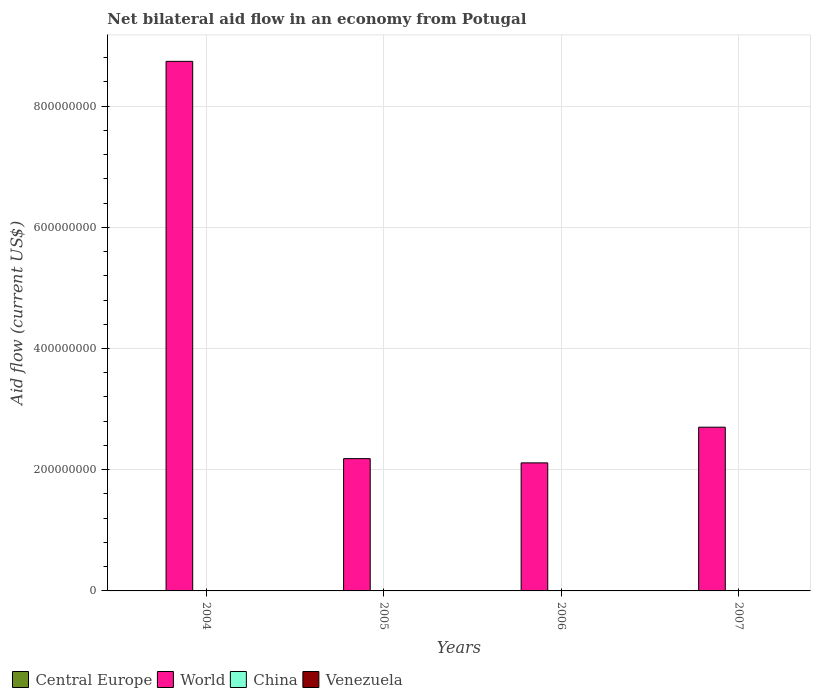How many different coloured bars are there?
Offer a very short reply. 4. How many groups of bars are there?
Provide a succinct answer. 4. Are the number of bars per tick equal to the number of legend labels?
Make the answer very short. Yes. How many bars are there on the 3rd tick from the left?
Provide a short and direct response. 4. In how many cases, is the number of bars for a given year not equal to the number of legend labels?
Provide a short and direct response. 0. Across all years, what is the maximum net bilateral aid flow in Central Europe?
Your answer should be compact. 5.50e+05. Across all years, what is the minimum net bilateral aid flow in Venezuela?
Make the answer very short. 8.00e+04. In which year was the net bilateral aid flow in Venezuela maximum?
Your answer should be very brief. 2007. What is the total net bilateral aid flow in Venezuela in the graph?
Make the answer very short. 4.40e+05. What is the difference between the net bilateral aid flow in World in 2004 and that in 2007?
Provide a succinct answer. 6.04e+08. What is the difference between the net bilateral aid flow in Central Europe in 2007 and the net bilateral aid flow in World in 2006?
Offer a terse response. -2.11e+08. In the year 2005, what is the difference between the net bilateral aid flow in China and net bilateral aid flow in Venezuela?
Give a very brief answer. 1.70e+05. In how many years, is the net bilateral aid flow in Venezuela greater than 640000000 US$?
Make the answer very short. 0. What is the ratio of the net bilateral aid flow in Central Europe in 2004 to that in 2007?
Offer a terse response. 4.58. What is the difference between the highest and the lowest net bilateral aid flow in China?
Offer a very short reply. 1.70e+05. In how many years, is the net bilateral aid flow in Venezuela greater than the average net bilateral aid flow in Venezuela taken over all years?
Offer a very short reply. 1. Is it the case that in every year, the sum of the net bilateral aid flow in Central Europe and net bilateral aid flow in China is greater than the sum of net bilateral aid flow in World and net bilateral aid flow in Venezuela?
Provide a short and direct response. No. What does the 1st bar from the left in 2004 represents?
Ensure brevity in your answer.  Central Europe. What does the 4th bar from the right in 2006 represents?
Your answer should be compact. Central Europe. Is it the case that in every year, the sum of the net bilateral aid flow in Venezuela and net bilateral aid flow in China is greater than the net bilateral aid flow in Central Europe?
Keep it short and to the point. No. How many bars are there?
Provide a short and direct response. 16. Are the values on the major ticks of Y-axis written in scientific E-notation?
Provide a succinct answer. No. Where does the legend appear in the graph?
Provide a succinct answer. Bottom left. How are the legend labels stacked?
Offer a terse response. Horizontal. What is the title of the graph?
Your answer should be very brief. Net bilateral aid flow in an economy from Potugal. What is the label or title of the X-axis?
Provide a succinct answer. Years. What is the label or title of the Y-axis?
Your answer should be very brief. Aid flow (current US$). What is the Aid flow (current US$) of Central Europe in 2004?
Offer a very short reply. 5.50e+05. What is the Aid flow (current US$) in World in 2004?
Your answer should be very brief. 8.74e+08. What is the Aid flow (current US$) in Venezuela in 2004?
Ensure brevity in your answer.  8.00e+04. What is the Aid flow (current US$) of Central Europe in 2005?
Offer a terse response. 5.00e+04. What is the Aid flow (current US$) in World in 2005?
Provide a short and direct response. 2.18e+08. What is the Aid flow (current US$) of China in 2005?
Give a very brief answer. 2.70e+05. What is the Aid flow (current US$) in Venezuela in 2005?
Your response must be concise. 1.00e+05. What is the Aid flow (current US$) in Central Europe in 2006?
Offer a very short reply. 8.00e+04. What is the Aid flow (current US$) in World in 2006?
Give a very brief answer. 2.11e+08. What is the Aid flow (current US$) of Venezuela in 2006?
Make the answer very short. 1.10e+05. What is the Aid flow (current US$) in Central Europe in 2007?
Make the answer very short. 1.20e+05. What is the Aid flow (current US$) of World in 2007?
Give a very brief answer. 2.70e+08. What is the Aid flow (current US$) of China in 2007?
Ensure brevity in your answer.  1.50e+05. What is the Aid flow (current US$) of Venezuela in 2007?
Offer a terse response. 1.50e+05. Across all years, what is the maximum Aid flow (current US$) in Central Europe?
Give a very brief answer. 5.50e+05. Across all years, what is the maximum Aid flow (current US$) in World?
Provide a short and direct response. 8.74e+08. Across all years, what is the maximum Aid flow (current US$) in China?
Ensure brevity in your answer.  3.00e+05. Across all years, what is the maximum Aid flow (current US$) of Venezuela?
Make the answer very short. 1.50e+05. Across all years, what is the minimum Aid flow (current US$) of Central Europe?
Provide a succinct answer. 5.00e+04. Across all years, what is the minimum Aid flow (current US$) of World?
Make the answer very short. 2.11e+08. Across all years, what is the minimum Aid flow (current US$) in Venezuela?
Keep it short and to the point. 8.00e+04. What is the total Aid flow (current US$) in Central Europe in the graph?
Give a very brief answer. 8.00e+05. What is the total Aid flow (current US$) of World in the graph?
Make the answer very short. 1.57e+09. What is the total Aid flow (current US$) of China in the graph?
Provide a short and direct response. 8.50e+05. What is the total Aid flow (current US$) in Venezuela in the graph?
Make the answer very short. 4.40e+05. What is the difference between the Aid flow (current US$) in World in 2004 and that in 2005?
Give a very brief answer. 6.56e+08. What is the difference between the Aid flow (current US$) of China in 2004 and that in 2005?
Provide a succinct answer. 3.00e+04. What is the difference between the Aid flow (current US$) in Venezuela in 2004 and that in 2005?
Your answer should be very brief. -2.00e+04. What is the difference between the Aid flow (current US$) in World in 2004 and that in 2006?
Offer a very short reply. 6.63e+08. What is the difference between the Aid flow (current US$) of Venezuela in 2004 and that in 2006?
Make the answer very short. -3.00e+04. What is the difference between the Aid flow (current US$) in World in 2004 and that in 2007?
Provide a succinct answer. 6.04e+08. What is the difference between the Aid flow (current US$) in Venezuela in 2004 and that in 2007?
Give a very brief answer. -7.00e+04. What is the difference between the Aid flow (current US$) of World in 2005 and that in 2006?
Keep it short and to the point. 7.01e+06. What is the difference between the Aid flow (current US$) in China in 2005 and that in 2006?
Provide a succinct answer. 1.40e+05. What is the difference between the Aid flow (current US$) in Venezuela in 2005 and that in 2006?
Provide a succinct answer. -10000. What is the difference between the Aid flow (current US$) of World in 2005 and that in 2007?
Provide a succinct answer. -5.19e+07. What is the difference between the Aid flow (current US$) of World in 2006 and that in 2007?
Offer a very short reply. -5.89e+07. What is the difference between the Aid flow (current US$) of Venezuela in 2006 and that in 2007?
Give a very brief answer. -4.00e+04. What is the difference between the Aid flow (current US$) of Central Europe in 2004 and the Aid flow (current US$) of World in 2005?
Give a very brief answer. -2.18e+08. What is the difference between the Aid flow (current US$) in Central Europe in 2004 and the Aid flow (current US$) in China in 2005?
Your answer should be very brief. 2.80e+05. What is the difference between the Aid flow (current US$) of Central Europe in 2004 and the Aid flow (current US$) of Venezuela in 2005?
Provide a short and direct response. 4.50e+05. What is the difference between the Aid flow (current US$) of World in 2004 and the Aid flow (current US$) of China in 2005?
Ensure brevity in your answer.  8.74e+08. What is the difference between the Aid flow (current US$) in World in 2004 and the Aid flow (current US$) in Venezuela in 2005?
Ensure brevity in your answer.  8.74e+08. What is the difference between the Aid flow (current US$) in China in 2004 and the Aid flow (current US$) in Venezuela in 2005?
Provide a short and direct response. 2.00e+05. What is the difference between the Aid flow (current US$) in Central Europe in 2004 and the Aid flow (current US$) in World in 2006?
Your response must be concise. -2.11e+08. What is the difference between the Aid flow (current US$) in Central Europe in 2004 and the Aid flow (current US$) in Venezuela in 2006?
Your response must be concise. 4.40e+05. What is the difference between the Aid flow (current US$) of World in 2004 and the Aid flow (current US$) of China in 2006?
Provide a succinct answer. 8.74e+08. What is the difference between the Aid flow (current US$) of World in 2004 and the Aid flow (current US$) of Venezuela in 2006?
Provide a short and direct response. 8.74e+08. What is the difference between the Aid flow (current US$) in Central Europe in 2004 and the Aid flow (current US$) in World in 2007?
Ensure brevity in your answer.  -2.70e+08. What is the difference between the Aid flow (current US$) of Central Europe in 2004 and the Aid flow (current US$) of China in 2007?
Offer a terse response. 4.00e+05. What is the difference between the Aid flow (current US$) of Central Europe in 2004 and the Aid flow (current US$) of Venezuela in 2007?
Offer a terse response. 4.00e+05. What is the difference between the Aid flow (current US$) of World in 2004 and the Aid flow (current US$) of China in 2007?
Your answer should be compact. 8.74e+08. What is the difference between the Aid flow (current US$) of World in 2004 and the Aid flow (current US$) of Venezuela in 2007?
Keep it short and to the point. 8.74e+08. What is the difference between the Aid flow (current US$) in Central Europe in 2005 and the Aid flow (current US$) in World in 2006?
Your answer should be very brief. -2.11e+08. What is the difference between the Aid flow (current US$) of Central Europe in 2005 and the Aid flow (current US$) of China in 2006?
Offer a terse response. -8.00e+04. What is the difference between the Aid flow (current US$) of World in 2005 and the Aid flow (current US$) of China in 2006?
Your answer should be very brief. 2.18e+08. What is the difference between the Aid flow (current US$) of World in 2005 and the Aid flow (current US$) of Venezuela in 2006?
Provide a short and direct response. 2.18e+08. What is the difference between the Aid flow (current US$) of Central Europe in 2005 and the Aid flow (current US$) of World in 2007?
Your answer should be compact. -2.70e+08. What is the difference between the Aid flow (current US$) of Central Europe in 2005 and the Aid flow (current US$) of Venezuela in 2007?
Offer a terse response. -1.00e+05. What is the difference between the Aid flow (current US$) of World in 2005 and the Aid flow (current US$) of China in 2007?
Provide a succinct answer. 2.18e+08. What is the difference between the Aid flow (current US$) of World in 2005 and the Aid flow (current US$) of Venezuela in 2007?
Provide a short and direct response. 2.18e+08. What is the difference between the Aid flow (current US$) in China in 2005 and the Aid flow (current US$) in Venezuela in 2007?
Offer a very short reply. 1.20e+05. What is the difference between the Aid flow (current US$) of Central Europe in 2006 and the Aid flow (current US$) of World in 2007?
Give a very brief answer. -2.70e+08. What is the difference between the Aid flow (current US$) in Central Europe in 2006 and the Aid flow (current US$) in China in 2007?
Provide a succinct answer. -7.00e+04. What is the difference between the Aid flow (current US$) in Central Europe in 2006 and the Aid flow (current US$) in Venezuela in 2007?
Keep it short and to the point. -7.00e+04. What is the difference between the Aid flow (current US$) in World in 2006 and the Aid flow (current US$) in China in 2007?
Make the answer very short. 2.11e+08. What is the difference between the Aid flow (current US$) of World in 2006 and the Aid flow (current US$) of Venezuela in 2007?
Provide a succinct answer. 2.11e+08. What is the average Aid flow (current US$) in Central Europe per year?
Your answer should be very brief. 2.00e+05. What is the average Aid flow (current US$) of World per year?
Give a very brief answer. 3.93e+08. What is the average Aid flow (current US$) of China per year?
Offer a terse response. 2.12e+05. What is the average Aid flow (current US$) of Venezuela per year?
Make the answer very short. 1.10e+05. In the year 2004, what is the difference between the Aid flow (current US$) in Central Europe and Aid flow (current US$) in World?
Offer a very short reply. -8.73e+08. In the year 2004, what is the difference between the Aid flow (current US$) of Central Europe and Aid flow (current US$) of China?
Your response must be concise. 2.50e+05. In the year 2004, what is the difference between the Aid flow (current US$) in World and Aid flow (current US$) in China?
Your answer should be very brief. 8.74e+08. In the year 2004, what is the difference between the Aid flow (current US$) in World and Aid flow (current US$) in Venezuela?
Offer a terse response. 8.74e+08. In the year 2004, what is the difference between the Aid flow (current US$) in China and Aid flow (current US$) in Venezuela?
Your answer should be very brief. 2.20e+05. In the year 2005, what is the difference between the Aid flow (current US$) in Central Europe and Aid flow (current US$) in World?
Offer a terse response. -2.18e+08. In the year 2005, what is the difference between the Aid flow (current US$) in World and Aid flow (current US$) in China?
Provide a short and direct response. 2.18e+08. In the year 2005, what is the difference between the Aid flow (current US$) of World and Aid flow (current US$) of Venezuela?
Your answer should be compact. 2.18e+08. In the year 2005, what is the difference between the Aid flow (current US$) in China and Aid flow (current US$) in Venezuela?
Provide a short and direct response. 1.70e+05. In the year 2006, what is the difference between the Aid flow (current US$) of Central Europe and Aid flow (current US$) of World?
Your answer should be very brief. -2.11e+08. In the year 2006, what is the difference between the Aid flow (current US$) of Central Europe and Aid flow (current US$) of China?
Ensure brevity in your answer.  -5.00e+04. In the year 2006, what is the difference between the Aid flow (current US$) in World and Aid flow (current US$) in China?
Ensure brevity in your answer.  2.11e+08. In the year 2006, what is the difference between the Aid flow (current US$) in World and Aid flow (current US$) in Venezuela?
Your answer should be very brief. 2.11e+08. In the year 2006, what is the difference between the Aid flow (current US$) in China and Aid flow (current US$) in Venezuela?
Give a very brief answer. 2.00e+04. In the year 2007, what is the difference between the Aid flow (current US$) in Central Europe and Aid flow (current US$) in World?
Give a very brief answer. -2.70e+08. In the year 2007, what is the difference between the Aid flow (current US$) in Central Europe and Aid flow (current US$) in China?
Give a very brief answer. -3.00e+04. In the year 2007, what is the difference between the Aid flow (current US$) of Central Europe and Aid flow (current US$) of Venezuela?
Make the answer very short. -3.00e+04. In the year 2007, what is the difference between the Aid flow (current US$) of World and Aid flow (current US$) of China?
Give a very brief answer. 2.70e+08. In the year 2007, what is the difference between the Aid flow (current US$) of World and Aid flow (current US$) of Venezuela?
Offer a very short reply. 2.70e+08. In the year 2007, what is the difference between the Aid flow (current US$) in China and Aid flow (current US$) in Venezuela?
Make the answer very short. 0. What is the ratio of the Aid flow (current US$) in Central Europe in 2004 to that in 2005?
Your answer should be compact. 11. What is the ratio of the Aid flow (current US$) in World in 2004 to that in 2005?
Your response must be concise. 4. What is the ratio of the Aid flow (current US$) of Central Europe in 2004 to that in 2006?
Offer a very short reply. 6.88. What is the ratio of the Aid flow (current US$) of World in 2004 to that in 2006?
Offer a terse response. 4.14. What is the ratio of the Aid flow (current US$) in China in 2004 to that in 2006?
Your response must be concise. 2.31. What is the ratio of the Aid flow (current US$) of Venezuela in 2004 to that in 2006?
Ensure brevity in your answer.  0.73. What is the ratio of the Aid flow (current US$) of Central Europe in 2004 to that in 2007?
Keep it short and to the point. 4.58. What is the ratio of the Aid flow (current US$) in World in 2004 to that in 2007?
Your answer should be compact. 3.23. What is the ratio of the Aid flow (current US$) in China in 2004 to that in 2007?
Offer a very short reply. 2. What is the ratio of the Aid flow (current US$) of Venezuela in 2004 to that in 2007?
Provide a succinct answer. 0.53. What is the ratio of the Aid flow (current US$) of World in 2005 to that in 2006?
Provide a succinct answer. 1.03. What is the ratio of the Aid flow (current US$) of China in 2005 to that in 2006?
Your answer should be very brief. 2.08. What is the ratio of the Aid flow (current US$) in Venezuela in 2005 to that in 2006?
Offer a very short reply. 0.91. What is the ratio of the Aid flow (current US$) of Central Europe in 2005 to that in 2007?
Make the answer very short. 0.42. What is the ratio of the Aid flow (current US$) of World in 2005 to that in 2007?
Provide a succinct answer. 0.81. What is the ratio of the Aid flow (current US$) in Central Europe in 2006 to that in 2007?
Ensure brevity in your answer.  0.67. What is the ratio of the Aid flow (current US$) in World in 2006 to that in 2007?
Give a very brief answer. 0.78. What is the ratio of the Aid flow (current US$) of China in 2006 to that in 2007?
Your response must be concise. 0.87. What is the ratio of the Aid flow (current US$) of Venezuela in 2006 to that in 2007?
Give a very brief answer. 0.73. What is the difference between the highest and the second highest Aid flow (current US$) of Central Europe?
Your answer should be very brief. 4.30e+05. What is the difference between the highest and the second highest Aid flow (current US$) of World?
Provide a short and direct response. 6.04e+08. What is the difference between the highest and the second highest Aid flow (current US$) of China?
Your response must be concise. 3.00e+04. What is the difference between the highest and the lowest Aid flow (current US$) in Central Europe?
Your response must be concise. 5.00e+05. What is the difference between the highest and the lowest Aid flow (current US$) in World?
Your response must be concise. 6.63e+08. What is the difference between the highest and the lowest Aid flow (current US$) in Venezuela?
Ensure brevity in your answer.  7.00e+04. 